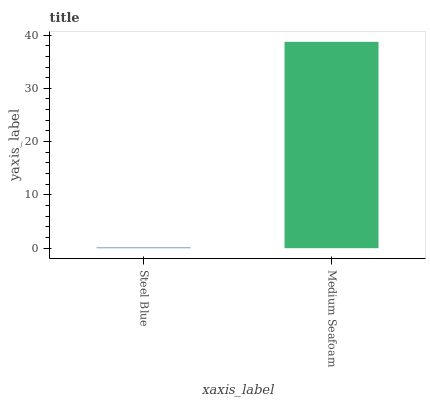Is Steel Blue the minimum?
Answer yes or no. Yes. Is Medium Seafoam the maximum?
Answer yes or no. Yes. Is Medium Seafoam the minimum?
Answer yes or no. No. Is Medium Seafoam greater than Steel Blue?
Answer yes or no. Yes. Is Steel Blue less than Medium Seafoam?
Answer yes or no. Yes. Is Steel Blue greater than Medium Seafoam?
Answer yes or no. No. Is Medium Seafoam less than Steel Blue?
Answer yes or no. No. Is Medium Seafoam the high median?
Answer yes or no. Yes. Is Steel Blue the low median?
Answer yes or no. Yes. Is Steel Blue the high median?
Answer yes or no. No. Is Medium Seafoam the low median?
Answer yes or no. No. 